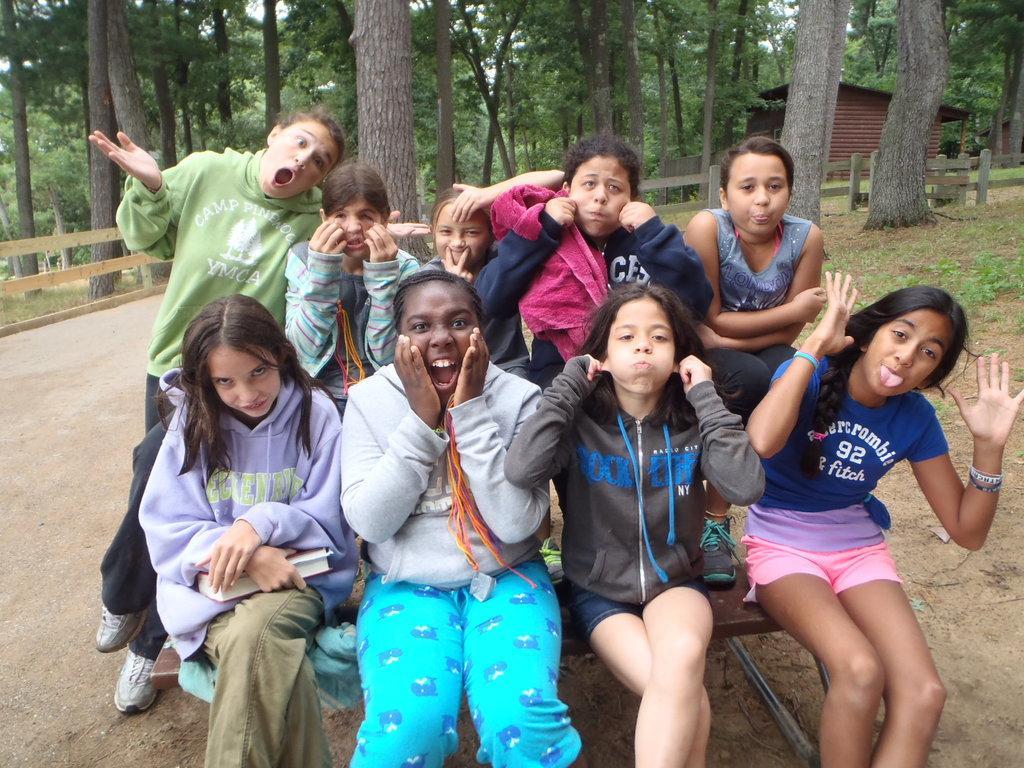Could you give a brief overview of what you see in this image? In this image in the middle, there is a girl, she wears a t shirt, trouser and there are four girls, they are sitting on the bench, behind them there are five people. In the background there are trees, house, fence, grassland. At the bottom there is land. 